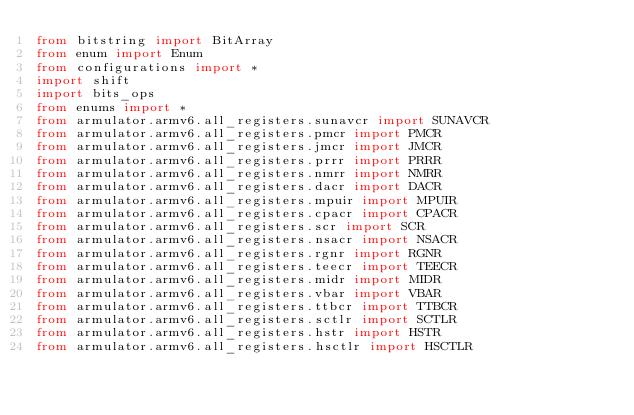Convert code to text. <code><loc_0><loc_0><loc_500><loc_500><_Python_>from bitstring import BitArray
from enum import Enum
from configurations import *
import shift
import bits_ops
from enums import *
from armulator.armv6.all_registers.sunavcr import SUNAVCR
from armulator.armv6.all_registers.pmcr import PMCR
from armulator.armv6.all_registers.jmcr import JMCR
from armulator.armv6.all_registers.prrr import PRRR
from armulator.armv6.all_registers.nmrr import NMRR
from armulator.armv6.all_registers.dacr import DACR
from armulator.armv6.all_registers.mpuir import MPUIR
from armulator.armv6.all_registers.cpacr import CPACR
from armulator.armv6.all_registers.scr import SCR
from armulator.armv6.all_registers.nsacr import NSACR
from armulator.armv6.all_registers.rgnr import RGNR
from armulator.armv6.all_registers.teecr import TEECR
from armulator.armv6.all_registers.midr import MIDR
from armulator.armv6.all_registers.vbar import VBAR
from armulator.armv6.all_registers.ttbcr import TTBCR
from armulator.armv6.all_registers.sctlr import SCTLR
from armulator.armv6.all_registers.hstr import HSTR
from armulator.armv6.all_registers.hsctlr import HSCTLR</code> 